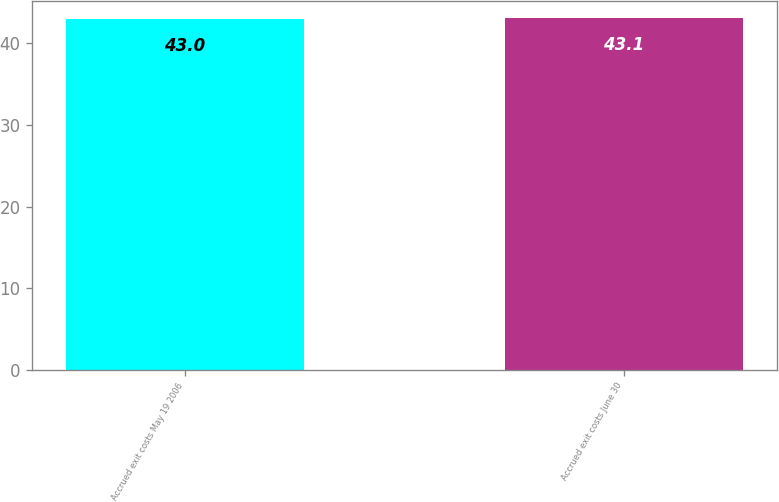<chart> <loc_0><loc_0><loc_500><loc_500><bar_chart><fcel>Accrued exit costs May 19 2006<fcel>Accrued exit costs June 30<nl><fcel>43<fcel>43.1<nl></chart> 